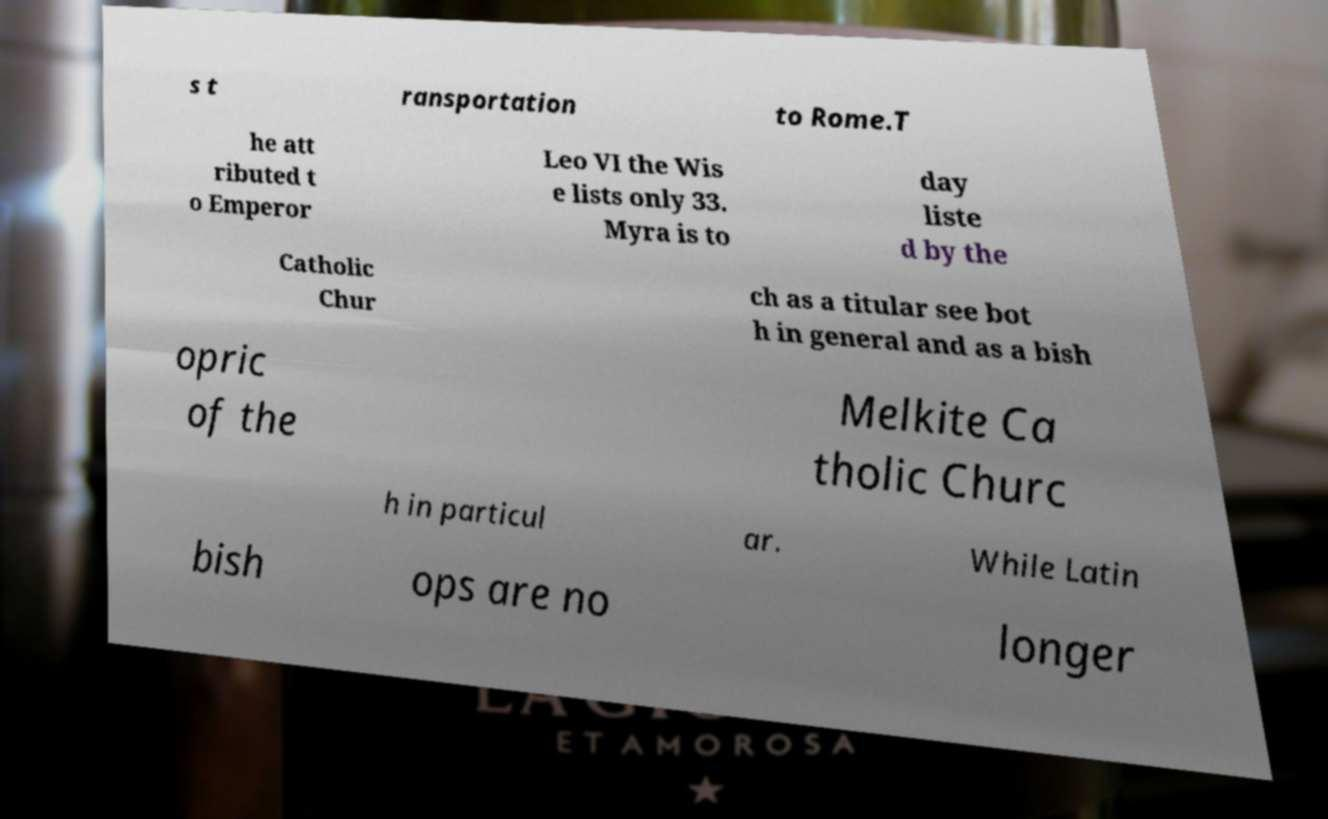Could you extract and type out the text from this image? s t ransportation to Rome.T he att ributed t o Emperor Leo VI the Wis e lists only 33. Myra is to day liste d by the Catholic Chur ch as a titular see bot h in general and as a bish opric of the Melkite Ca tholic Churc h in particul ar. While Latin bish ops are no longer 